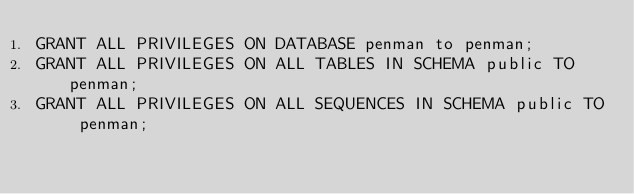Convert code to text. <code><loc_0><loc_0><loc_500><loc_500><_SQL_>GRANT ALL PRIVILEGES ON DATABASE penman to penman;
GRANT ALL PRIVILEGES ON ALL TABLES IN SCHEMA public TO penman;
GRANT ALL PRIVILEGES ON ALL SEQUENCES IN SCHEMA public TO penman;
</code> 